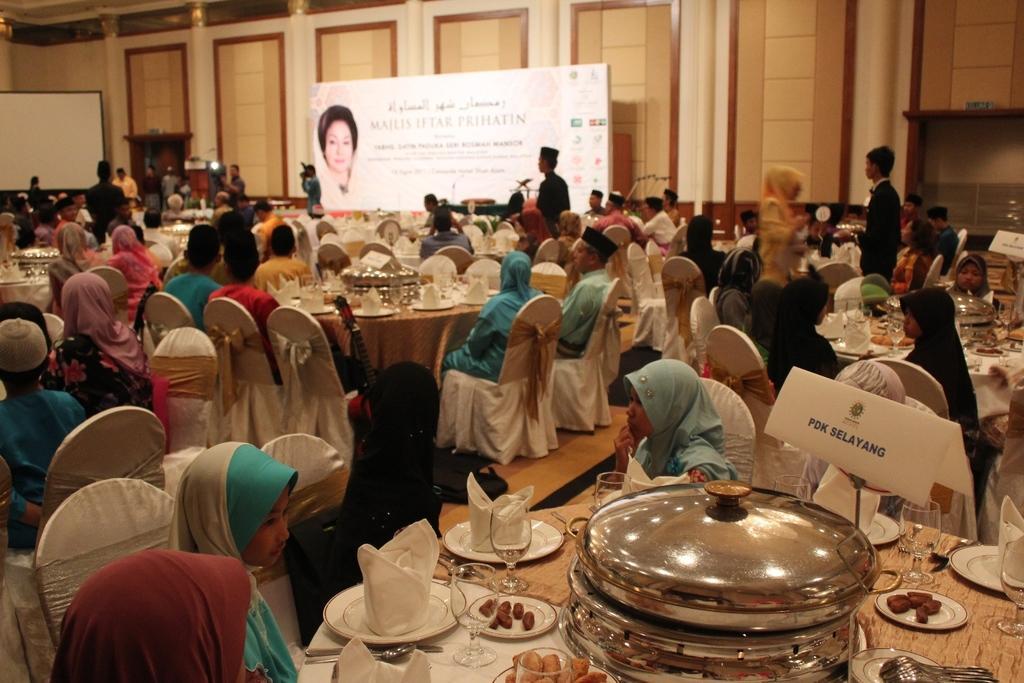Please provide a concise description of this image. In this image we can see a group of people who are sitting on a chair. They are having a food. Here we can see a hoarding which in on the top center to the room. 